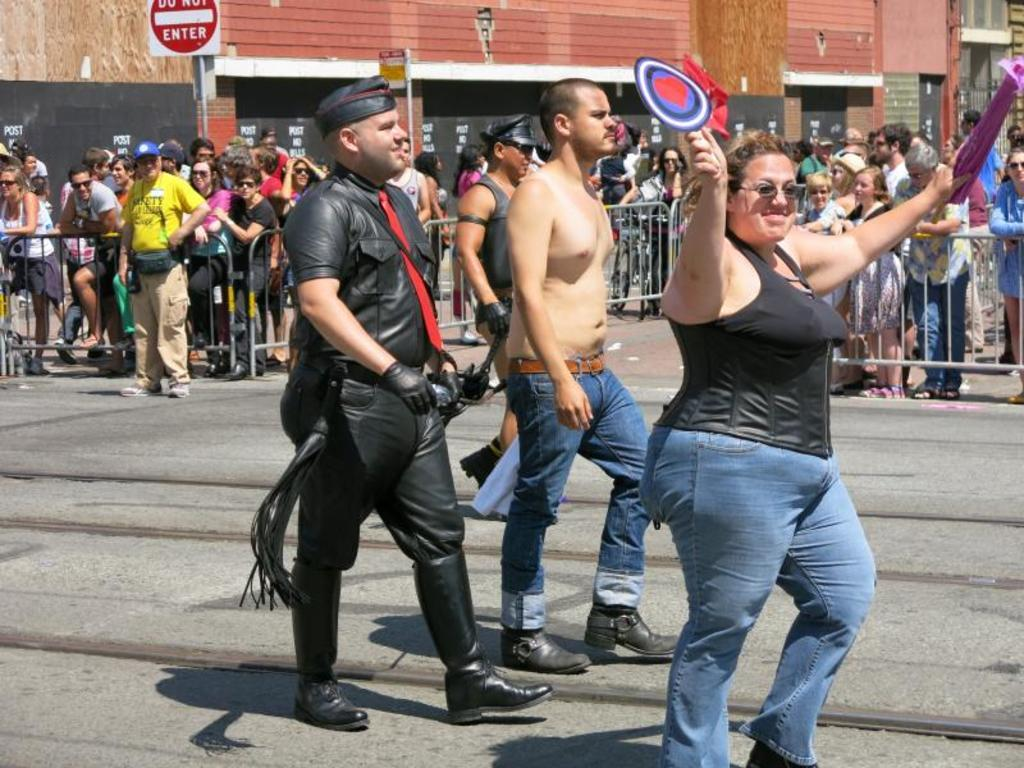How many people are present in the image? There are three people in the image. What can be seen in the background of the image? There is a wall, people, a fence, and boards in the background of the image. What is the woman in the image doing? The woman is holding objects in the image. What type of bomb can be seen in the image? There is no bomb present in the image. What flavor of jam is being spread on the bread in the image? There is no bread or jam present in the image. 